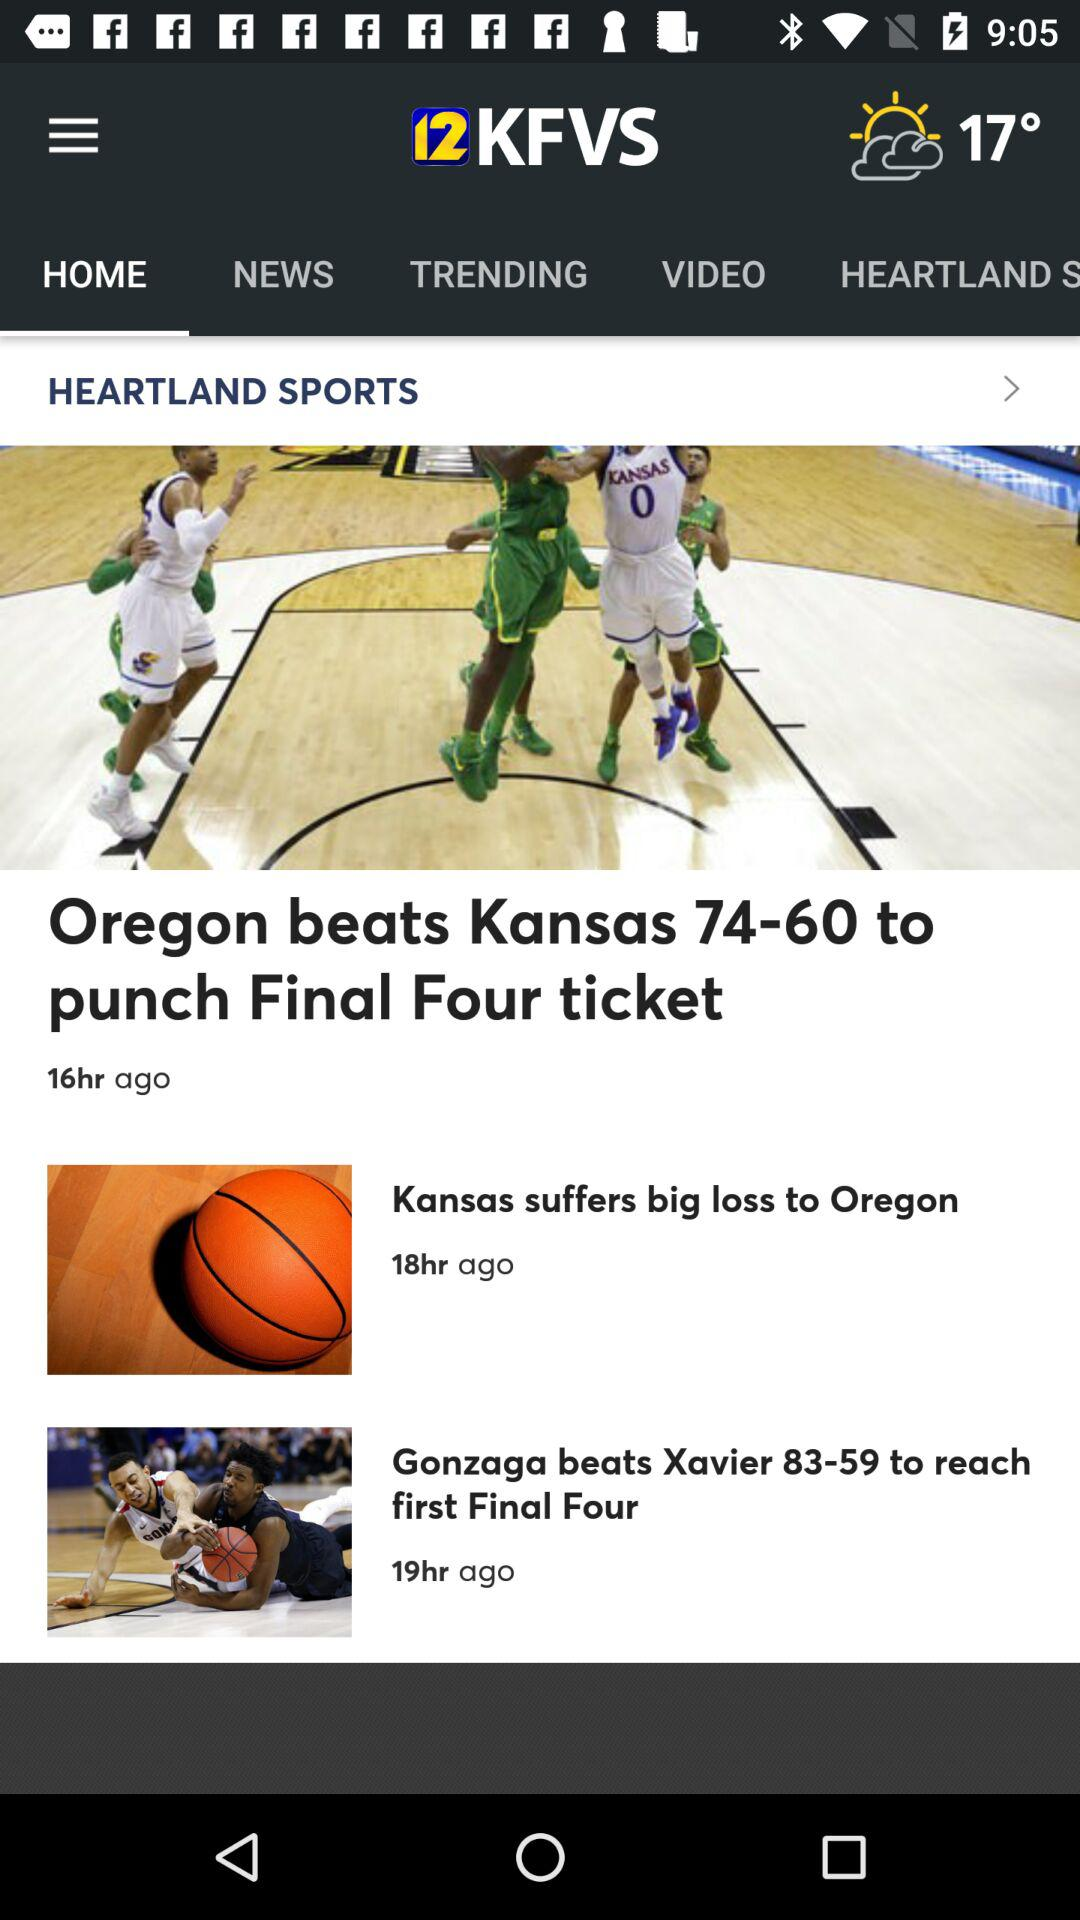How's the weather? The weather is partly cloudy. 